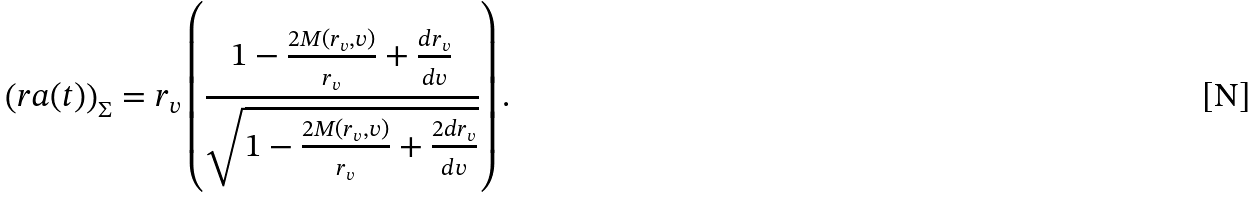Convert formula to latex. <formula><loc_0><loc_0><loc_500><loc_500>\left ( r a ( t ) \right ) _ { \Sigma } = r _ { v } \left ( \frac { 1 - \frac { 2 M ( r _ { v } , v ) } { r _ { v } } + \frac { d r _ { v } } { d v } } { \sqrt { 1 - \frac { 2 M ( r _ { v } , v ) } { r _ { v } } + \frac { 2 d r _ { v } } { d v } } } \right ) .</formula> 